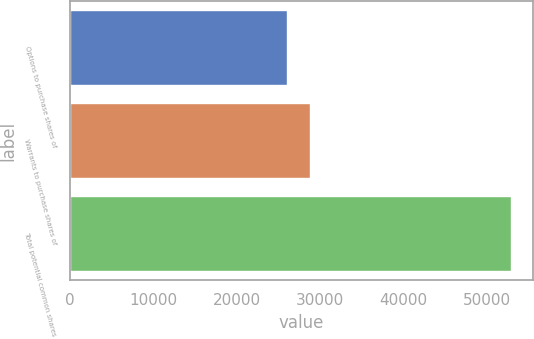<chart> <loc_0><loc_0><loc_500><loc_500><bar_chart><fcel>Options to purchase shares of<fcel>Warrants to purchase shares of<fcel>Total potential common shares<nl><fcel>26039<fcel>28721.9<fcel>52868<nl></chart> 